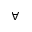<formula> <loc_0><loc_0><loc_500><loc_500>\forall</formula> 